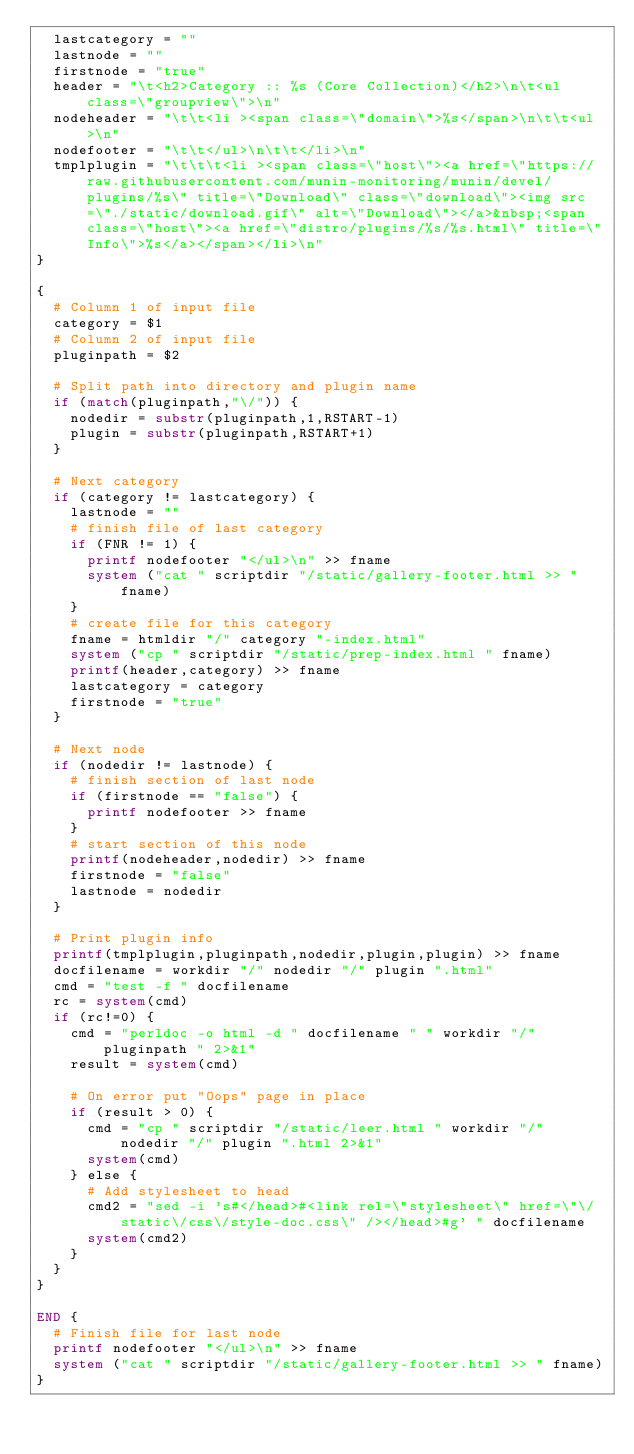<code> <loc_0><loc_0><loc_500><loc_500><_Awk_>  lastcategory = ""
  lastnode = ""
  firstnode = "true"
  header = "\t<h2>Category :: %s (Core Collection)</h2>\n\t<ul class=\"groupview\">\n"
  nodeheader = "\t\t<li ><span class=\"domain\">%s</span>\n\t\t<ul>\n"
  nodefooter = "\t\t</ul>\n\t\t</li>\n"
  tmplplugin = "\t\t\t<li ><span class=\"host\"><a href=\"https://raw.githubusercontent.com/munin-monitoring/munin/devel/plugins/%s\" title=\"Download\" class=\"download\"><img src=\"./static/download.gif\" alt=\"Download\"></a>&nbsp;<span class=\"host\"><a href=\"distro/plugins/%s/%s.html\" title=\"Info\">%s</a></span></li>\n"
}

{
  # Column 1 of input file
  category = $1
  # Column 2 of input file
  pluginpath = $2

  # Split path into directory and plugin name
  if (match(pluginpath,"\/")) {
    nodedir = substr(pluginpath,1,RSTART-1)
    plugin = substr(pluginpath,RSTART+1)
  }

  # Next category
  if (category != lastcategory) {
    lastnode = ""
    # finish file of last category
    if (FNR != 1) {
      printf nodefooter "</ul>\n" >> fname
      system ("cat " scriptdir "/static/gallery-footer.html >> " fname) 
    }
    # create file for this category
    fname = htmldir "/" category "-index.html"
    system ("cp " scriptdir "/static/prep-index.html " fname)
    printf(header,category) >> fname
    lastcategory = category
    firstnode = "true"
  }

  # Next node
  if (nodedir != lastnode) {
    # finish section of last node
    if (firstnode == "false") {
      printf nodefooter >> fname
    }
    # start section of this node
    printf(nodeheader,nodedir) >> fname
    firstnode = "false"
    lastnode = nodedir
  }

  # Print plugin info
  printf(tmplplugin,pluginpath,nodedir,plugin,plugin) >> fname
  docfilename = workdir "/" nodedir "/" plugin ".html"
  cmd = "test -f " docfilename
  rc = system(cmd)
  if (rc!=0) {
    cmd = "perldoc -o html -d " docfilename " " workdir "/" pluginpath " 2>&1"
    result = system(cmd)

    # On error put "Oops" page in place
    if (result > 0) {
      cmd = "cp " scriptdir "/static/leer.html " workdir "/" nodedir "/" plugin ".html 2>&1"
      system(cmd)
    } else {
      # Add stylesheet to head
      cmd2 = "sed -i 's#</head>#<link rel=\"stylesheet\" href=\"\/static\/css\/style-doc.css\" /></head>#g' " docfilename
      system(cmd2)
    }
  }
}

END {
  # Finish file for last node
  printf nodefooter "</ul>\n" >> fname
  system ("cat " scriptdir "/static/gallery-footer.html >> " fname) 
}
</code> 